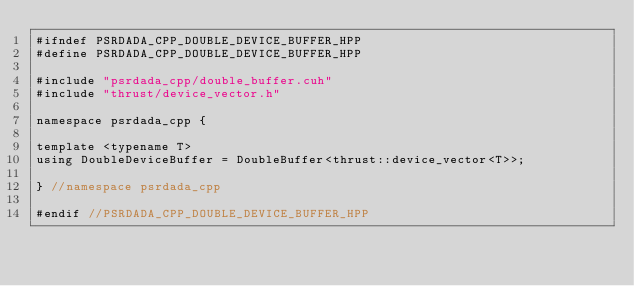<code> <loc_0><loc_0><loc_500><loc_500><_Cuda_>#ifndef PSRDADA_CPP_DOUBLE_DEVICE_BUFFER_HPP
#define PSRDADA_CPP_DOUBLE_DEVICE_BUFFER_HPP

#include "psrdada_cpp/double_buffer.cuh"
#include "thrust/device_vector.h"

namespace psrdada_cpp {

template <typename T>
using DoubleDeviceBuffer = DoubleBuffer<thrust::device_vector<T>>;

} //namespace psrdada_cpp

#endif //PSRDADA_CPP_DOUBLE_DEVICE_BUFFER_HPP
</code> 